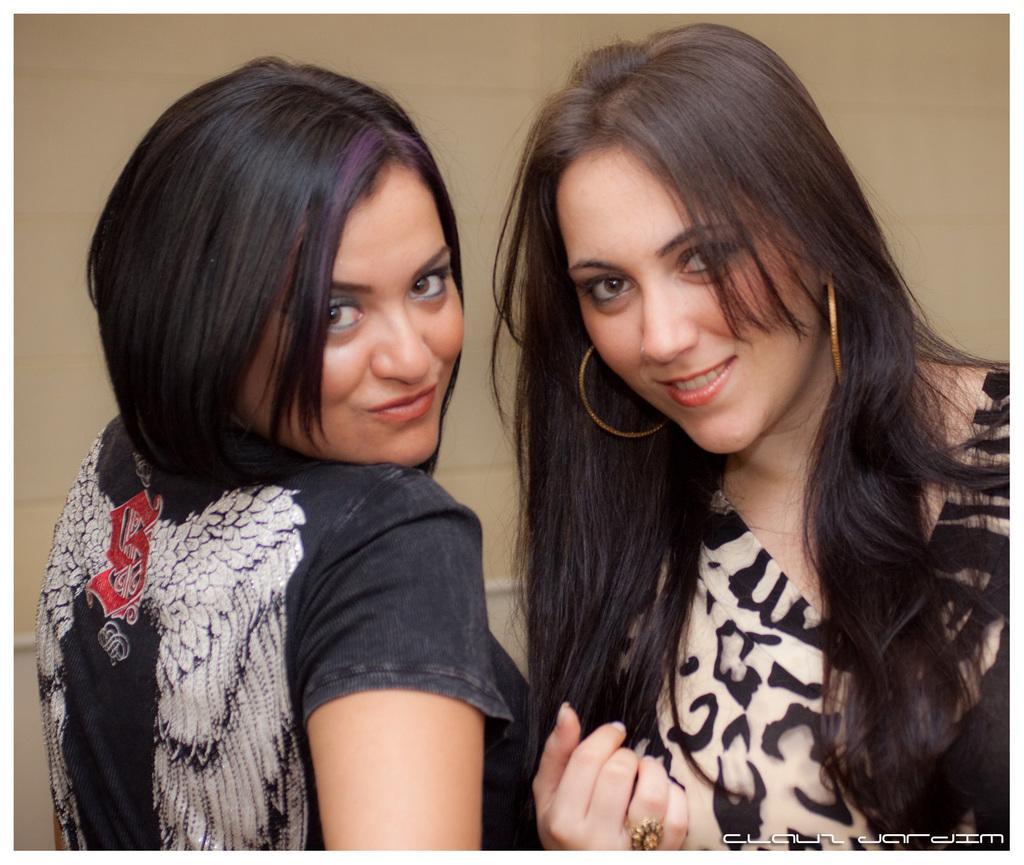How would you summarize this image in a sentence or two? In this image we can see two women wearing dresses are smiling. In the background, we can see the wall. Here we can see the watermark on the bottom right side of the image. 